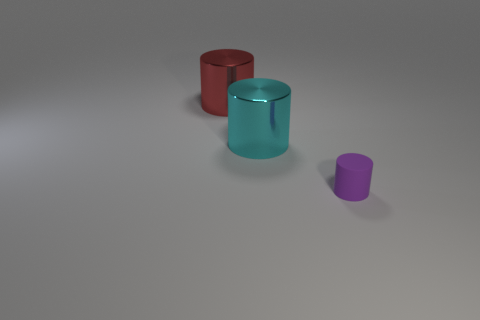There is a cyan object; are there any tiny purple things behind it?
Make the answer very short. No. Do the purple matte thing and the object that is behind the large cyan object have the same shape?
Your answer should be compact. Yes. How many things are either large metal objects that are to the left of the big cyan metal object or small green matte blocks?
Provide a short and direct response. 1. Are there any other things that have the same material as the small thing?
Provide a short and direct response. No. What number of things are both on the left side of the small rubber cylinder and in front of the big red metallic thing?
Keep it short and to the point. 1. What number of objects are either cylinders to the right of the cyan metal cylinder or tiny rubber things in front of the red cylinder?
Provide a short and direct response. 1. How many other things are there of the same shape as the red metallic object?
Your answer should be compact. 2. There is a shiny object behind the cyan metal thing; is its color the same as the small cylinder?
Your response must be concise. No. What number of other things are there of the same size as the red cylinder?
Make the answer very short. 1. Do the large red thing and the tiny thing have the same material?
Provide a succinct answer. No. 